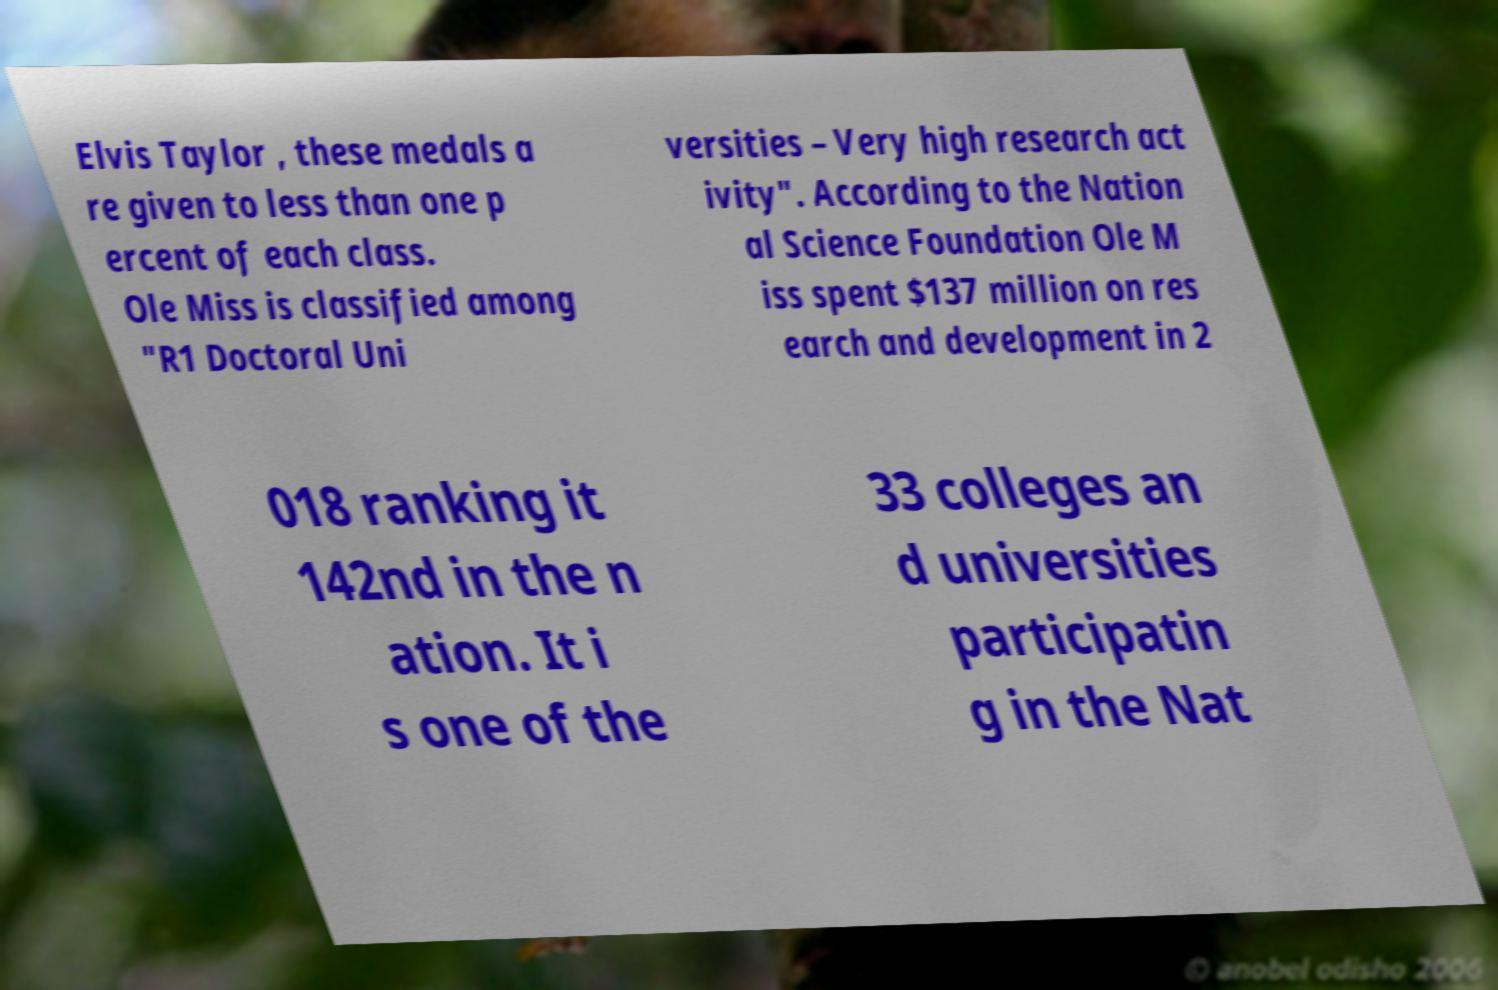Can you accurately transcribe the text from the provided image for me? Elvis Taylor , these medals a re given to less than one p ercent of each class. Ole Miss is classified among "R1 Doctoral Uni versities – Very high research act ivity". According to the Nation al Science Foundation Ole M iss spent $137 million on res earch and development in 2 018 ranking it 142nd in the n ation. It i s one of the 33 colleges an d universities participatin g in the Nat 